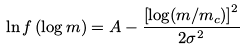Convert formula to latex. <formula><loc_0><loc_0><loc_500><loc_500>\ln f \left ( \log m \right ) = A - \frac { \left [ \log ( m / m _ { c } ) \right ] ^ { 2 } } { 2 \sigma ^ { 2 } }</formula> 